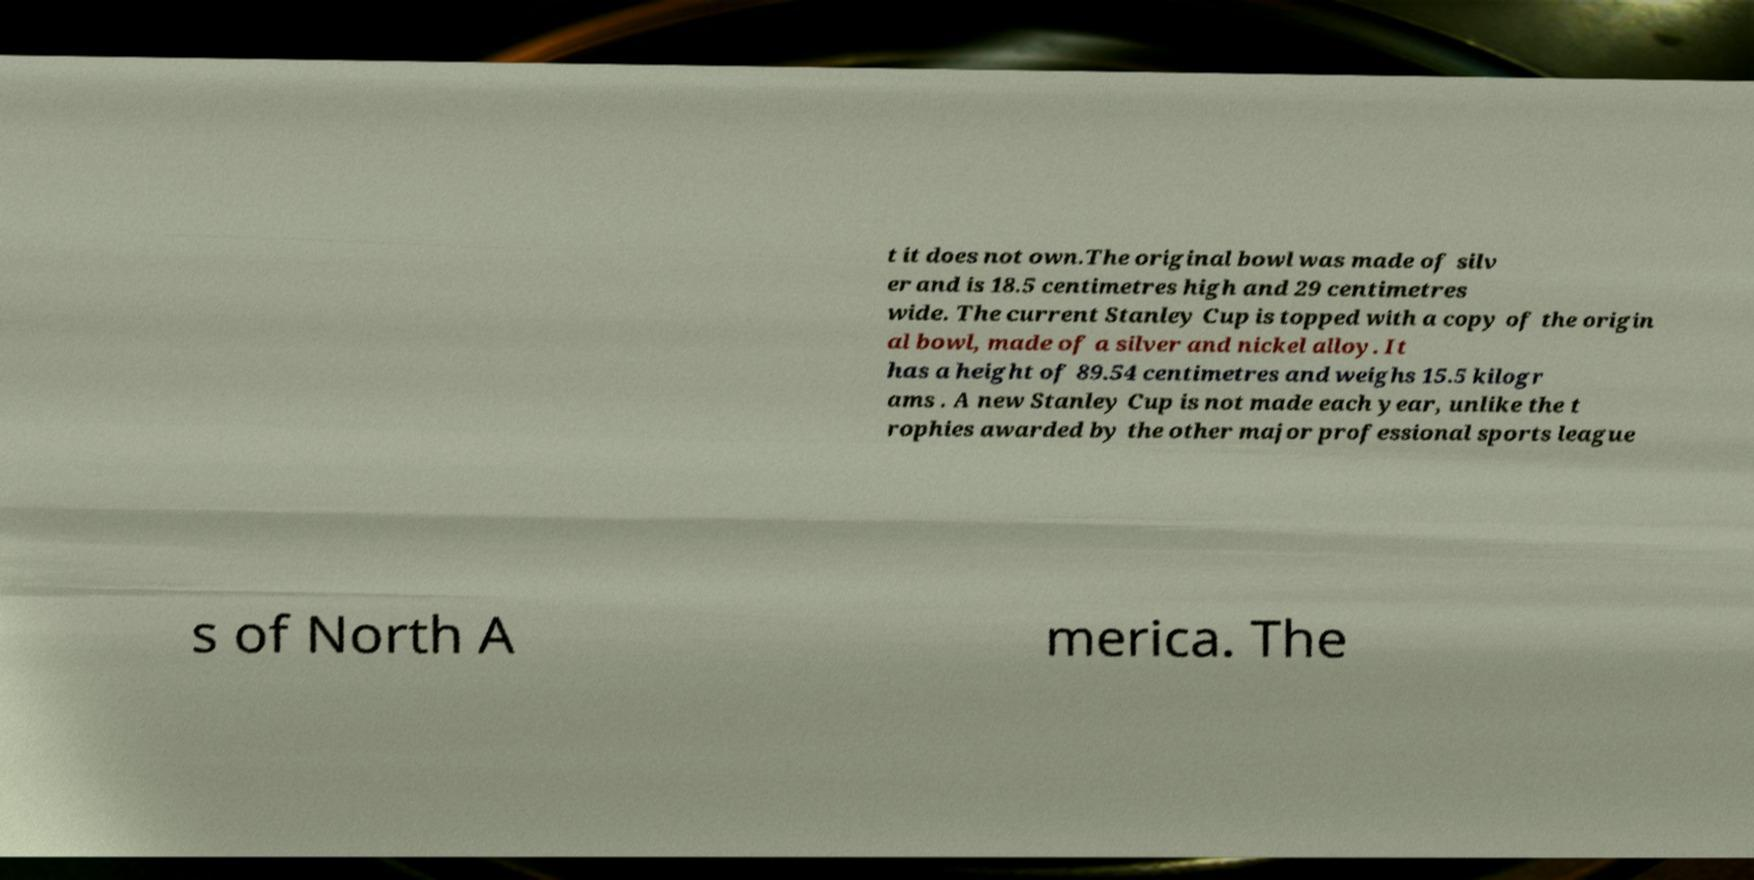Please identify and transcribe the text found in this image. t it does not own.The original bowl was made of silv er and is 18.5 centimetres high and 29 centimetres wide. The current Stanley Cup is topped with a copy of the origin al bowl, made of a silver and nickel alloy. It has a height of 89.54 centimetres and weighs 15.5 kilogr ams . A new Stanley Cup is not made each year, unlike the t rophies awarded by the other major professional sports league s of North A merica. The 